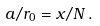Convert formula to latex. <formula><loc_0><loc_0><loc_500><loc_500>a / r _ { 0 } = x / N \, .</formula> 